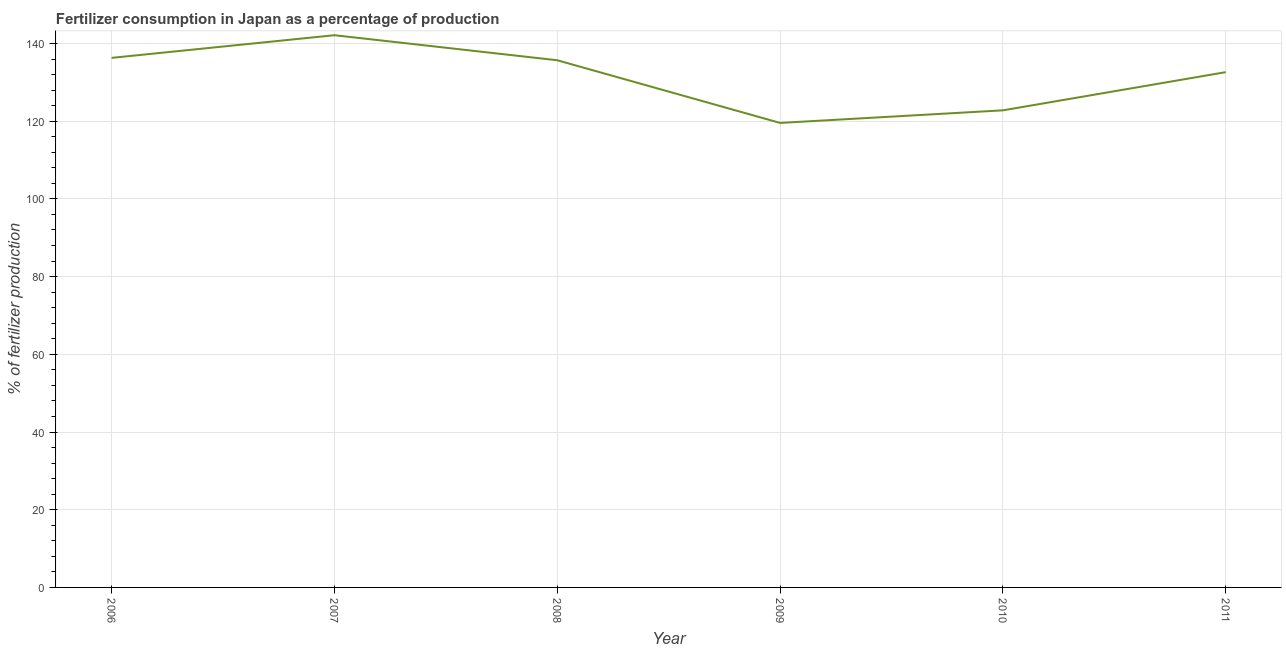What is the amount of fertilizer consumption in 2011?
Your response must be concise. 132.62. Across all years, what is the maximum amount of fertilizer consumption?
Keep it short and to the point. 142.13. Across all years, what is the minimum amount of fertilizer consumption?
Keep it short and to the point. 119.55. What is the sum of the amount of fertilizer consumption?
Keep it short and to the point. 789.07. What is the difference between the amount of fertilizer consumption in 2007 and 2009?
Offer a very short reply. 22.58. What is the average amount of fertilizer consumption per year?
Offer a very short reply. 131.51. What is the median amount of fertilizer consumption?
Offer a terse response. 134.15. Do a majority of the years between 2009 and 2008 (inclusive) have amount of fertilizer consumption greater than 124 %?
Offer a terse response. No. What is the ratio of the amount of fertilizer consumption in 2007 to that in 2010?
Offer a very short reply. 1.16. Is the difference between the amount of fertilizer consumption in 2007 and 2010 greater than the difference between any two years?
Make the answer very short. No. What is the difference between the highest and the second highest amount of fertilizer consumption?
Keep it short and to the point. 5.83. What is the difference between the highest and the lowest amount of fertilizer consumption?
Provide a short and direct response. 22.58. How many lines are there?
Your answer should be compact. 1. Are the values on the major ticks of Y-axis written in scientific E-notation?
Your answer should be very brief. No. Does the graph contain any zero values?
Offer a terse response. No. Does the graph contain grids?
Your answer should be compact. Yes. What is the title of the graph?
Make the answer very short. Fertilizer consumption in Japan as a percentage of production. What is the label or title of the X-axis?
Your answer should be very brief. Year. What is the label or title of the Y-axis?
Offer a very short reply. % of fertilizer production. What is the % of fertilizer production in 2006?
Make the answer very short. 136.3. What is the % of fertilizer production of 2007?
Give a very brief answer. 142.13. What is the % of fertilizer production in 2008?
Ensure brevity in your answer.  135.68. What is the % of fertilizer production in 2009?
Give a very brief answer. 119.55. What is the % of fertilizer production in 2010?
Your answer should be compact. 122.8. What is the % of fertilizer production of 2011?
Ensure brevity in your answer.  132.62. What is the difference between the % of fertilizer production in 2006 and 2007?
Make the answer very short. -5.83. What is the difference between the % of fertilizer production in 2006 and 2008?
Offer a terse response. 0.62. What is the difference between the % of fertilizer production in 2006 and 2009?
Make the answer very short. 16.74. What is the difference between the % of fertilizer production in 2006 and 2010?
Ensure brevity in your answer.  13.5. What is the difference between the % of fertilizer production in 2006 and 2011?
Give a very brief answer. 3.68. What is the difference between the % of fertilizer production in 2007 and 2008?
Give a very brief answer. 6.45. What is the difference between the % of fertilizer production in 2007 and 2009?
Keep it short and to the point. 22.58. What is the difference between the % of fertilizer production in 2007 and 2010?
Ensure brevity in your answer.  19.33. What is the difference between the % of fertilizer production in 2007 and 2011?
Your answer should be compact. 9.51. What is the difference between the % of fertilizer production in 2008 and 2009?
Give a very brief answer. 16.13. What is the difference between the % of fertilizer production in 2008 and 2010?
Ensure brevity in your answer.  12.88. What is the difference between the % of fertilizer production in 2008 and 2011?
Make the answer very short. 3.06. What is the difference between the % of fertilizer production in 2009 and 2010?
Make the answer very short. -3.24. What is the difference between the % of fertilizer production in 2009 and 2011?
Your answer should be compact. -13.07. What is the difference between the % of fertilizer production in 2010 and 2011?
Ensure brevity in your answer.  -9.82. What is the ratio of the % of fertilizer production in 2006 to that in 2007?
Make the answer very short. 0.96. What is the ratio of the % of fertilizer production in 2006 to that in 2009?
Make the answer very short. 1.14. What is the ratio of the % of fertilizer production in 2006 to that in 2010?
Offer a very short reply. 1.11. What is the ratio of the % of fertilizer production in 2006 to that in 2011?
Offer a very short reply. 1.03. What is the ratio of the % of fertilizer production in 2007 to that in 2008?
Your answer should be compact. 1.05. What is the ratio of the % of fertilizer production in 2007 to that in 2009?
Your answer should be very brief. 1.19. What is the ratio of the % of fertilizer production in 2007 to that in 2010?
Make the answer very short. 1.16. What is the ratio of the % of fertilizer production in 2007 to that in 2011?
Your response must be concise. 1.07. What is the ratio of the % of fertilizer production in 2008 to that in 2009?
Your answer should be very brief. 1.14. What is the ratio of the % of fertilizer production in 2008 to that in 2010?
Keep it short and to the point. 1.1. What is the ratio of the % of fertilizer production in 2009 to that in 2011?
Provide a succinct answer. 0.9. What is the ratio of the % of fertilizer production in 2010 to that in 2011?
Your answer should be compact. 0.93. 